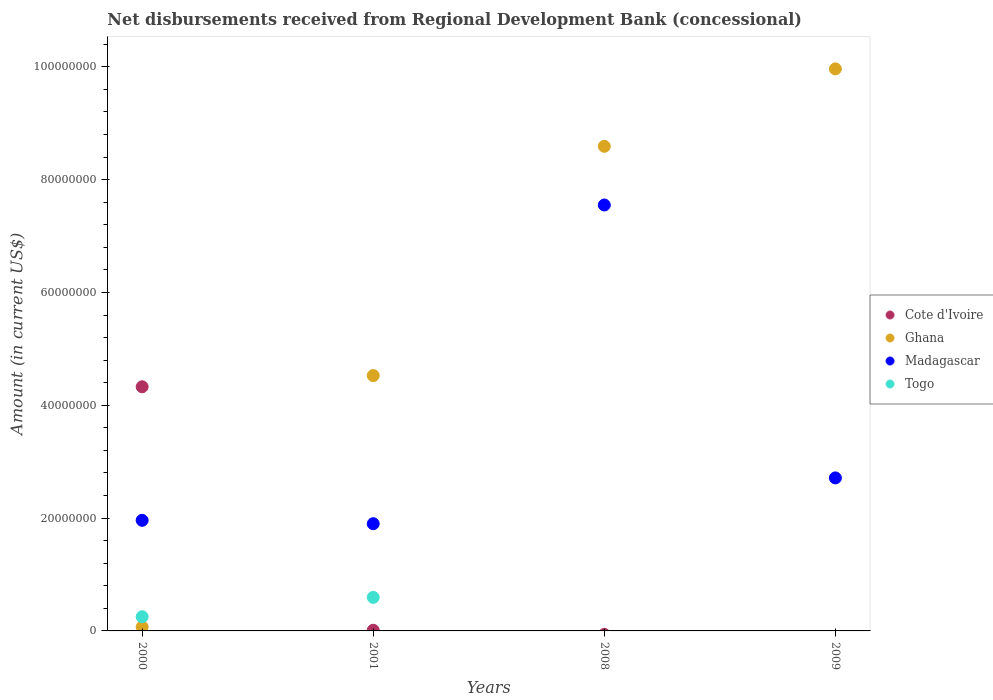How many different coloured dotlines are there?
Give a very brief answer. 4. What is the amount of disbursements received from Regional Development Bank in Ghana in 2009?
Your answer should be very brief. 9.96e+07. Across all years, what is the maximum amount of disbursements received from Regional Development Bank in Madagascar?
Your answer should be compact. 7.55e+07. Across all years, what is the minimum amount of disbursements received from Regional Development Bank in Togo?
Your response must be concise. 0. What is the total amount of disbursements received from Regional Development Bank in Madagascar in the graph?
Offer a very short reply. 1.41e+08. What is the difference between the amount of disbursements received from Regional Development Bank in Madagascar in 2000 and that in 2008?
Provide a short and direct response. -5.59e+07. What is the difference between the amount of disbursements received from Regional Development Bank in Cote d'Ivoire in 2001 and the amount of disbursements received from Regional Development Bank in Ghana in 2009?
Your answer should be compact. -9.95e+07. What is the average amount of disbursements received from Regional Development Bank in Togo per year?
Your answer should be compact. 2.12e+06. In the year 2009, what is the difference between the amount of disbursements received from Regional Development Bank in Madagascar and amount of disbursements received from Regional Development Bank in Ghana?
Ensure brevity in your answer.  -7.25e+07. In how many years, is the amount of disbursements received from Regional Development Bank in Ghana greater than 28000000 US$?
Provide a short and direct response. 3. What is the ratio of the amount of disbursements received from Regional Development Bank in Togo in 2000 to that in 2001?
Keep it short and to the point. 0.42. Is the difference between the amount of disbursements received from Regional Development Bank in Madagascar in 2000 and 2008 greater than the difference between the amount of disbursements received from Regional Development Bank in Ghana in 2000 and 2008?
Your response must be concise. Yes. What is the difference between the highest and the second highest amount of disbursements received from Regional Development Bank in Ghana?
Offer a terse response. 1.37e+07. What is the difference between the highest and the lowest amount of disbursements received from Regional Development Bank in Cote d'Ivoire?
Ensure brevity in your answer.  4.33e+07. In how many years, is the amount of disbursements received from Regional Development Bank in Madagascar greater than the average amount of disbursements received from Regional Development Bank in Madagascar taken over all years?
Your answer should be very brief. 1. Is the sum of the amount of disbursements received from Regional Development Bank in Ghana in 2001 and 2009 greater than the maximum amount of disbursements received from Regional Development Bank in Madagascar across all years?
Offer a terse response. Yes. Is it the case that in every year, the sum of the amount of disbursements received from Regional Development Bank in Togo and amount of disbursements received from Regional Development Bank in Madagascar  is greater than the sum of amount of disbursements received from Regional Development Bank in Cote d'Ivoire and amount of disbursements received from Regional Development Bank in Ghana?
Make the answer very short. No. Is it the case that in every year, the sum of the amount of disbursements received from Regional Development Bank in Madagascar and amount of disbursements received from Regional Development Bank in Togo  is greater than the amount of disbursements received from Regional Development Bank in Cote d'Ivoire?
Ensure brevity in your answer.  No. Is the amount of disbursements received from Regional Development Bank in Cote d'Ivoire strictly greater than the amount of disbursements received from Regional Development Bank in Ghana over the years?
Give a very brief answer. No. Is the amount of disbursements received from Regional Development Bank in Togo strictly less than the amount of disbursements received from Regional Development Bank in Ghana over the years?
Your answer should be very brief. No. How many dotlines are there?
Provide a short and direct response. 4. How many years are there in the graph?
Keep it short and to the point. 4. Are the values on the major ticks of Y-axis written in scientific E-notation?
Provide a short and direct response. No. Does the graph contain any zero values?
Your response must be concise. Yes. How many legend labels are there?
Provide a short and direct response. 4. How are the legend labels stacked?
Your answer should be very brief. Vertical. What is the title of the graph?
Your response must be concise. Net disbursements received from Regional Development Bank (concessional). Does "Mozambique" appear as one of the legend labels in the graph?
Keep it short and to the point. No. What is the label or title of the X-axis?
Offer a very short reply. Years. What is the Amount (in current US$) in Cote d'Ivoire in 2000?
Keep it short and to the point. 4.33e+07. What is the Amount (in current US$) of Ghana in 2000?
Offer a terse response. 7.06e+05. What is the Amount (in current US$) in Madagascar in 2000?
Give a very brief answer. 1.96e+07. What is the Amount (in current US$) in Togo in 2000?
Ensure brevity in your answer.  2.52e+06. What is the Amount (in current US$) in Cote d'Ivoire in 2001?
Keep it short and to the point. 1.22e+05. What is the Amount (in current US$) of Ghana in 2001?
Ensure brevity in your answer.  4.53e+07. What is the Amount (in current US$) in Madagascar in 2001?
Keep it short and to the point. 1.90e+07. What is the Amount (in current US$) in Togo in 2001?
Provide a short and direct response. 5.95e+06. What is the Amount (in current US$) of Ghana in 2008?
Provide a short and direct response. 8.59e+07. What is the Amount (in current US$) in Madagascar in 2008?
Provide a short and direct response. 7.55e+07. What is the Amount (in current US$) in Togo in 2008?
Your answer should be very brief. 0. What is the Amount (in current US$) of Cote d'Ivoire in 2009?
Provide a succinct answer. 0. What is the Amount (in current US$) of Ghana in 2009?
Your answer should be very brief. 9.96e+07. What is the Amount (in current US$) in Madagascar in 2009?
Your answer should be compact. 2.71e+07. What is the Amount (in current US$) in Togo in 2009?
Your response must be concise. 0. Across all years, what is the maximum Amount (in current US$) of Cote d'Ivoire?
Make the answer very short. 4.33e+07. Across all years, what is the maximum Amount (in current US$) in Ghana?
Make the answer very short. 9.96e+07. Across all years, what is the maximum Amount (in current US$) in Madagascar?
Offer a terse response. 7.55e+07. Across all years, what is the maximum Amount (in current US$) of Togo?
Ensure brevity in your answer.  5.95e+06. Across all years, what is the minimum Amount (in current US$) in Cote d'Ivoire?
Your response must be concise. 0. Across all years, what is the minimum Amount (in current US$) of Ghana?
Your answer should be compact. 7.06e+05. Across all years, what is the minimum Amount (in current US$) of Madagascar?
Offer a very short reply. 1.90e+07. What is the total Amount (in current US$) of Cote d'Ivoire in the graph?
Your response must be concise. 4.34e+07. What is the total Amount (in current US$) in Ghana in the graph?
Offer a very short reply. 2.32e+08. What is the total Amount (in current US$) in Madagascar in the graph?
Keep it short and to the point. 1.41e+08. What is the total Amount (in current US$) in Togo in the graph?
Your answer should be compact. 8.46e+06. What is the difference between the Amount (in current US$) of Cote d'Ivoire in 2000 and that in 2001?
Make the answer very short. 4.32e+07. What is the difference between the Amount (in current US$) in Ghana in 2000 and that in 2001?
Make the answer very short. -4.46e+07. What is the difference between the Amount (in current US$) of Togo in 2000 and that in 2001?
Keep it short and to the point. -3.43e+06. What is the difference between the Amount (in current US$) in Ghana in 2000 and that in 2008?
Keep it short and to the point. -8.52e+07. What is the difference between the Amount (in current US$) in Madagascar in 2000 and that in 2008?
Your answer should be compact. -5.59e+07. What is the difference between the Amount (in current US$) in Ghana in 2000 and that in 2009?
Your response must be concise. -9.89e+07. What is the difference between the Amount (in current US$) of Madagascar in 2000 and that in 2009?
Make the answer very short. -7.52e+06. What is the difference between the Amount (in current US$) of Ghana in 2001 and that in 2008?
Your response must be concise. -4.06e+07. What is the difference between the Amount (in current US$) in Madagascar in 2001 and that in 2008?
Offer a terse response. -5.65e+07. What is the difference between the Amount (in current US$) of Ghana in 2001 and that in 2009?
Keep it short and to the point. -5.44e+07. What is the difference between the Amount (in current US$) in Madagascar in 2001 and that in 2009?
Offer a terse response. -8.12e+06. What is the difference between the Amount (in current US$) in Ghana in 2008 and that in 2009?
Your answer should be very brief. -1.37e+07. What is the difference between the Amount (in current US$) in Madagascar in 2008 and that in 2009?
Your answer should be compact. 4.84e+07. What is the difference between the Amount (in current US$) in Cote d'Ivoire in 2000 and the Amount (in current US$) in Ghana in 2001?
Provide a short and direct response. -1.99e+06. What is the difference between the Amount (in current US$) of Cote d'Ivoire in 2000 and the Amount (in current US$) of Madagascar in 2001?
Offer a terse response. 2.43e+07. What is the difference between the Amount (in current US$) in Cote d'Ivoire in 2000 and the Amount (in current US$) in Togo in 2001?
Keep it short and to the point. 3.73e+07. What is the difference between the Amount (in current US$) in Ghana in 2000 and the Amount (in current US$) in Madagascar in 2001?
Offer a terse response. -1.83e+07. What is the difference between the Amount (in current US$) in Ghana in 2000 and the Amount (in current US$) in Togo in 2001?
Offer a terse response. -5.24e+06. What is the difference between the Amount (in current US$) of Madagascar in 2000 and the Amount (in current US$) of Togo in 2001?
Provide a short and direct response. 1.37e+07. What is the difference between the Amount (in current US$) of Cote d'Ivoire in 2000 and the Amount (in current US$) of Ghana in 2008?
Provide a short and direct response. -4.26e+07. What is the difference between the Amount (in current US$) of Cote d'Ivoire in 2000 and the Amount (in current US$) of Madagascar in 2008?
Provide a short and direct response. -3.22e+07. What is the difference between the Amount (in current US$) of Ghana in 2000 and the Amount (in current US$) of Madagascar in 2008?
Make the answer very short. -7.48e+07. What is the difference between the Amount (in current US$) in Cote d'Ivoire in 2000 and the Amount (in current US$) in Ghana in 2009?
Your response must be concise. -5.64e+07. What is the difference between the Amount (in current US$) of Cote d'Ivoire in 2000 and the Amount (in current US$) of Madagascar in 2009?
Provide a succinct answer. 1.62e+07. What is the difference between the Amount (in current US$) in Ghana in 2000 and the Amount (in current US$) in Madagascar in 2009?
Keep it short and to the point. -2.64e+07. What is the difference between the Amount (in current US$) of Cote d'Ivoire in 2001 and the Amount (in current US$) of Ghana in 2008?
Your response must be concise. -8.58e+07. What is the difference between the Amount (in current US$) of Cote d'Ivoire in 2001 and the Amount (in current US$) of Madagascar in 2008?
Offer a terse response. -7.54e+07. What is the difference between the Amount (in current US$) of Ghana in 2001 and the Amount (in current US$) of Madagascar in 2008?
Give a very brief answer. -3.02e+07. What is the difference between the Amount (in current US$) of Cote d'Ivoire in 2001 and the Amount (in current US$) of Ghana in 2009?
Give a very brief answer. -9.95e+07. What is the difference between the Amount (in current US$) in Cote d'Ivoire in 2001 and the Amount (in current US$) in Madagascar in 2009?
Offer a terse response. -2.70e+07. What is the difference between the Amount (in current US$) of Ghana in 2001 and the Amount (in current US$) of Madagascar in 2009?
Offer a terse response. 1.81e+07. What is the difference between the Amount (in current US$) of Ghana in 2008 and the Amount (in current US$) of Madagascar in 2009?
Make the answer very short. 5.88e+07. What is the average Amount (in current US$) in Cote d'Ivoire per year?
Your answer should be very brief. 1.09e+07. What is the average Amount (in current US$) in Ghana per year?
Offer a terse response. 5.79e+07. What is the average Amount (in current US$) in Madagascar per year?
Offer a very short reply. 3.53e+07. What is the average Amount (in current US$) in Togo per year?
Provide a short and direct response. 2.12e+06. In the year 2000, what is the difference between the Amount (in current US$) in Cote d'Ivoire and Amount (in current US$) in Ghana?
Your response must be concise. 4.26e+07. In the year 2000, what is the difference between the Amount (in current US$) of Cote d'Ivoire and Amount (in current US$) of Madagascar?
Keep it short and to the point. 2.37e+07. In the year 2000, what is the difference between the Amount (in current US$) in Cote d'Ivoire and Amount (in current US$) in Togo?
Provide a short and direct response. 4.08e+07. In the year 2000, what is the difference between the Amount (in current US$) of Ghana and Amount (in current US$) of Madagascar?
Give a very brief answer. -1.89e+07. In the year 2000, what is the difference between the Amount (in current US$) of Ghana and Amount (in current US$) of Togo?
Offer a terse response. -1.81e+06. In the year 2000, what is the difference between the Amount (in current US$) of Madagascar and Amount (in current US$) of Togo?
Keep it short and to the point. 1.71e+07. In the year 2001, what is the difference between the Amount (in current US$) of Cote d'Ivoire and Amount (in current US$) of Ghana?
Ensure brevity in your answer.  -4.51e+07. In the year 2001, what is the difference between the Amount (in current US$) of Cote d'Ivoire and Amount (in current US$) of Madagascar?
Your answer should be compact. -1.89e+07. In the year 2001, what is the difference between the Amount (in current US$) of Cote d'Ivoire and Amount (in current US$) of Togo?
Offer a very short reply. -5.82e+06. In the year 2001, what is the difference between the Amount (in current US$) of Ghana and Amount (in current US$) of Madagascar?
Give a very brief answer. 2.63e+07. In the year 2001, what is the difference between the Amount (in current US$) in Ghana and Amount (in current US$) in Togo?
Offer a terse response. 3.93e+07. In the year 2001, what is the difference between the Amount (in current US$) of Madagascar and Amount (in current US$) of Togo?
Give a very brief answer. 1.31e+07. In the year 2008, what is the difference between the Amount (in current US$) of Ghana and Amount (in current US$) of Madagascar?
Make the answer very short. 1.04e+07. In the year 2009, what is the difference between the Amount (in current US$) in Ghana and Amount (in current US$) in Madagascar?
Ensure brevity in your answer.  7.25e+07. What is the ratio of the Amount (in current US$) in Cote d'Ivoire in 2000 to that in 2001?
Your response must be concise. 354.77. What is the ratio of the Amount (in current US$) in Ghana in 2000 to that in 2001?
Give a very brief answer. 0.02. What is the ratio of the Amount (in current US$) of Madagascar in 2000 to that in 2001?
Provide a succinct answer. 1.03. What is the ratio of the Amount (in current US$) of Togo in 2000 to that in 2001?
Your answer should be compact. 0.42. What is the ratio of the Amount (in current US$) of Ghana in 2000 to that in 2008?
Your response must be concise. 0.01. What is the ratio of the Amount (in current US$) of Madagascar in 2000 to that in 2008?
Provide a short and direct response. 0.26. What is the ratio of the Amount (in current US$) in Ghana in 2000 to that in 2009?
Offer a terse response. 0.01. What is the ratio of the Amount (in current US$) of Madagascar in 2000 to that in 2009?
Your answer should be compact. 0.72. What is the ratio of the Amount (in current US$) of Ghana in 2001 to that in 2008?
Provide a short and direct response. 0.53. What is the ratio of the Amount (in current US$) of Madagascar in 2001 to that in 2008?
Ensure brevity in your answer.  0.25. What is the ratio of the Amount (in current US$) of Ghana in 2001 to that in 2009?
Your answer should be compact. 0.45. What is the ratio of the Amount (in current US$) in Madagascar in 2001 to that in 2009?
Provide a succinct answer. 0.7. What is the ratio of the Amount (in current US$) of Ghana in 2008 to that in 2009?
Your response must be concise. 0.86. What is the ratio of the Amount (in current US$) in Madagascar in 2008 to that in 2009?
Give a very brief answer. 2.78. What is the difference between the highest and the second highest Amount (in current US$) of Ghana?
Offer a terse response. 1.37e+07. What is the difference between the highest and the second highest Amount (in current US$) of Madagascar?
Make the answer very short. 4.84e+07. What is the difference between the highest and the lowest Amount (in current US$) in Cote d'Ivoire?
Offer a very short reply. 4.33e+07. What is the difference between the highest and the lowest Amount (in current US$) in Ghana?
Offer a terse response. 9.89e+07. What is the difference between the highest and the lowest Amount (in current US$) in Madagascar?
Your answer should be compact. 5.65e+07. What is the difference between the highest and the lowest Amount (in current US$) in Togo?
Give a very brief answer. 5.95e+06. 